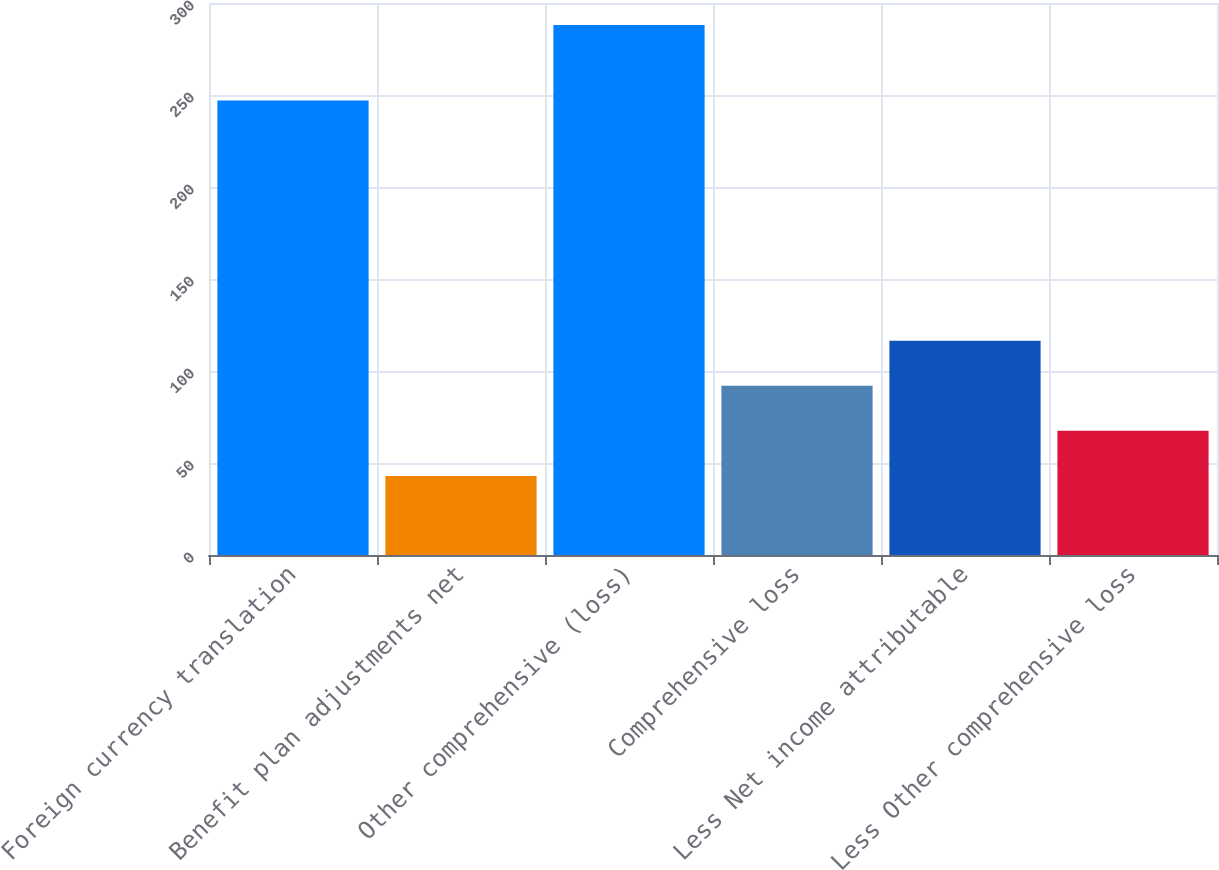Convert chart. <chart><loc_0><loc_0><loc_500><loc_500><bar_chart><fcel>Foreign currency translation<fcel>Benefit plan adjustments net<fcel>Other comprehensive (loss)<fcel>Comprehensive loss<fcel>Less Net income attributable<fcel>Less Other comprehensive loss<nl><fcel>247<fcel>43<fcel>288<fcel>92<fcel>116.5<fcel>67.5<nl></chart> 